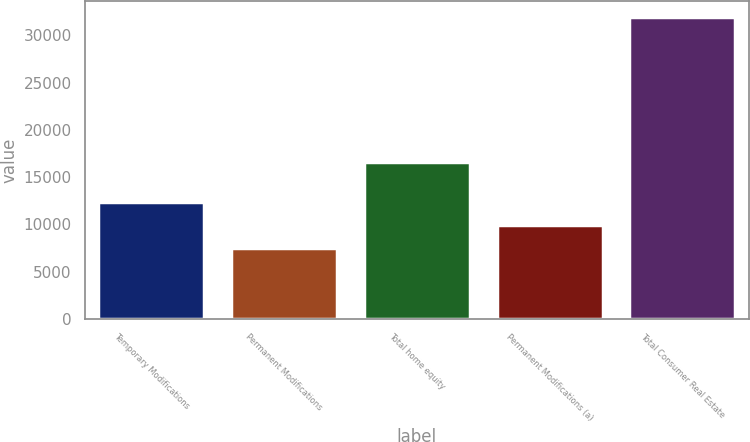Convert chart to OTSL. <chart><loc_0><loc_0><loc_500><loc_500><bar_chart><fcel>Temporary Modifications<fcel>Permanent Modifications<fcel>Total home equity<fcel>Permanent Modifications (a)<fcel>Total Consumer Real Estate<nl><fcel>12361.4<fcel>7457<fcel>16644<fcel>9909.2<fcel>31979<nl></chart> 